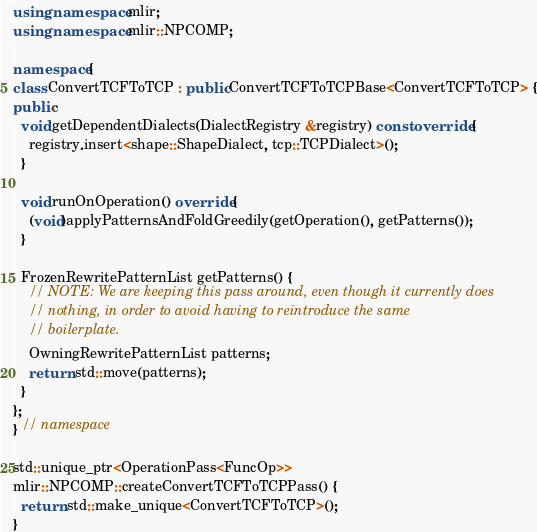<code> <loc_0><loc_0><loc_500><loc_500><_C++_>using namespace mlir;
using namespace mlir::NPCOMP;

namespace {
class ConvertTCFToTCP : public ConvertTCFToTCPBase<ConvertTCFToTCP> {
public:
  void getDependentDialects(DialectRegistry &registry) const override {
    registry.insert<shape::ShapeDialect, tcp::TCPDialect>();
  }

  void runOnOperation() override {
    (void)applyPatternsAndFoldGreedily(getOperation(), getPatterns());
  }

  FrozenRewritePatternList getPatterns() {
    // NOTE: We are keeping this pass around, even though it currently does
    // nothing, in order to avoid having to reintroduce the same
    // boilerplate.
    OwningRewritePatternList patterns;
    return std::move(patterns);
  }
};
} // namespace

std::unique_ptr<OperationPass<FuncOp>>
mlir::NPCOMP::createConvertTCFToTCPPass() {
  return std::make_unique<ConvertTCFToTCP>();
}
</code> 